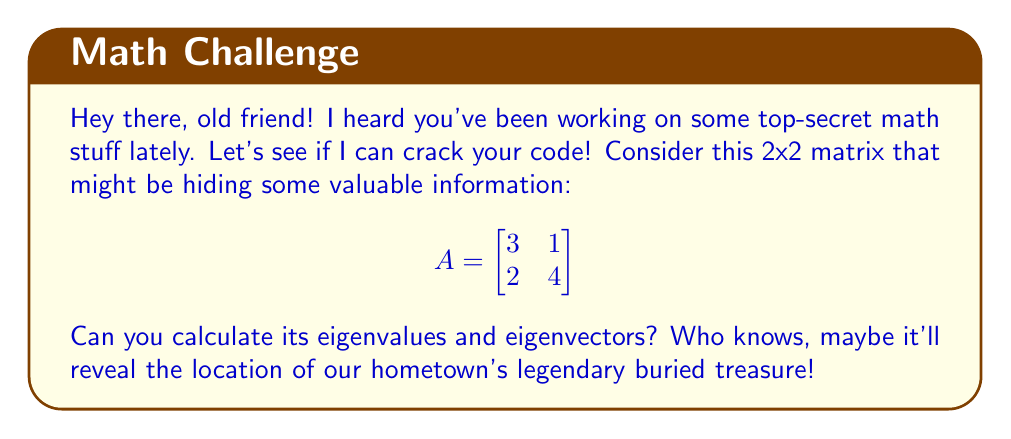Help me with this question. Alright, let's break this down step-by-step:

1) To find the eigenvalues, we need to solve the characteristic equation:
   $det(A - \lambda I) = 0$

2) Let's expand this:
   $$\begin{vmatrix}
   3-\lambda & 1 \\
   2 & 4-\lambda
   \end{vmatrix} = 0$$

3) This gives us:
   $(3-\lambda)(4-\lambda) - 2 = 0$

4) Expanding:
   $\lambda^2 - 7\lambda + 10 = 0$

5) This is a quadratic equation. We can solve it using the quadratic formula:
   $\lambda = \frac{-b \pm \sqrt{b^2 - 4ac}}{2a}$

6) Here, $a=1$, $b=-7$, and $c=10$. Plugging in:
   $\lambda = \frac{7 \pm \sqrt{49 - 40}}{2} = \frac{7 \pm 3}{2}$

7) So our eigenvalues are:
   $\lambda_1 = 5$ and $\lambda_2 = 2$

8) Now for the eigenvectors. For each eigenvalue, we solve $(A - \lambda I)v = 0$

9) For $\lambda_1 = 5$:
   $$\begin{bmatrix}
   -2 & 1 \\
   2 & -1
   \end{bmatrix}\begin{bmatrix}
   x \\
   y
   \end{bmatrix} = \begin{bmatrix}
   0 \\
   0
   \end{bmatrix}$$

   This gives us: $-2x + y = 0$, or $y = 2x$
   An eigenvector is $v_1 = \begin{bmatrix} 1 \\ 2 \end{bmatrix}$

10) For $\lambda_2 = 2$:
    $$\begin{bmatrix}
    1 & 1 \\
    2 & 2
    \end{bmatrix}\begin{bmatrix}
    x \\
    y
    \end{bmatrix} = \begin{bmatrix}
    0 \\
    0
    \end{bmatrix}$$

    This gives us: $x + y = 0$, or $y = -x$
    An eigenvector is $v_2 = \begin{bmatrix} 1 \\ -1 \end{bmatrix}$
Answer: Eigenvalues: $\lambda_1 = 5$, $\lambda_2 = 2$
Eigenvectors: $v_1 = \begin{bmatrix} 1 \\ 2 \end{bmatrix}$, $v_2 = \begin{bmatrix} 1 \\ -1 \end{bmatrix}$ 